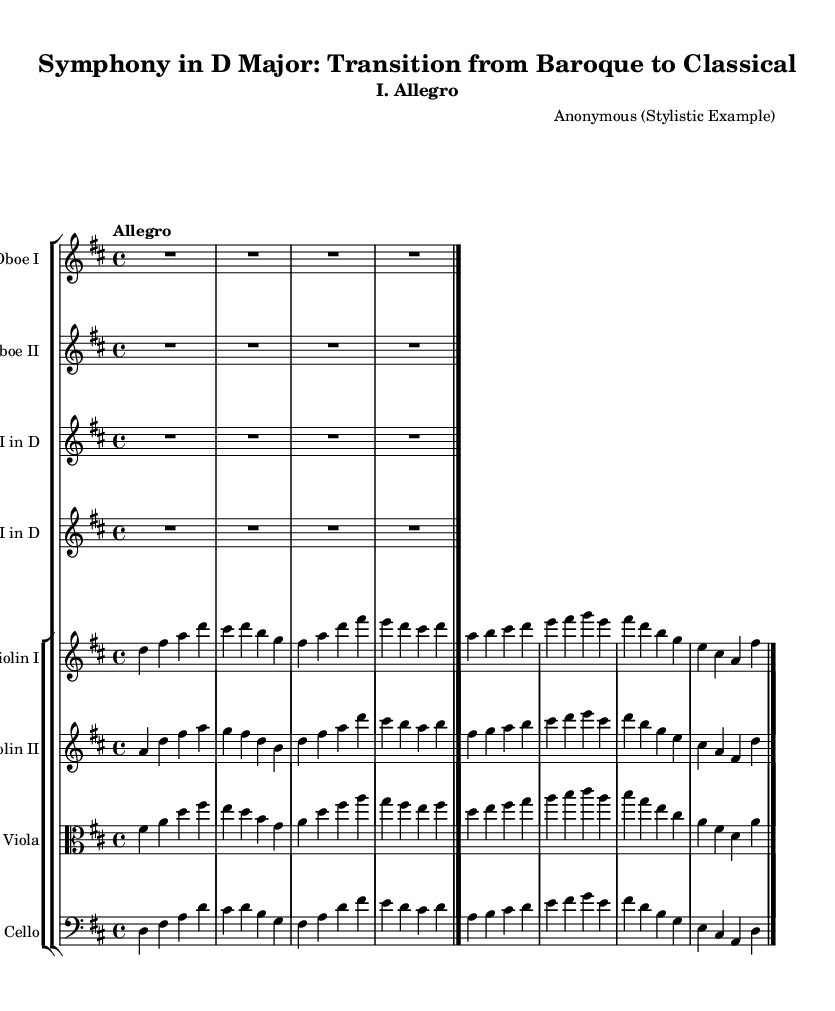What is the key signature of this music? The key signature indicates that the piece is in D major, which has two sharps (F# and C#). You can confirm this by locating the key signature at the beginning of the staff.
Answer: D major What is the time signature of this music? The time signature shown at the beginning of the staff is 4/4, indicating that there are four beats in each measure and the quarter note gets one beat. This can be found next to the clef and key signature.
Answer: 4/4 What is the tempo marking for this piece? The tempo marking written above the staff specifies "Allegro," which indicates a fast, lively pace. This is a typical tempo marking found in the performance direction at the start of the piece.
Answer: Allegro How many instruments are present in this score? The score features a total of six instruments: two violins, one viola, one cello, and two oboes, and two horns, confirmed by counting each instrumental part listed.
Answer: Six What structure is evident in the orchestration of this symphony? The orchestration shows a blend of strings (violins, viola, cello) and woodwinds (oboes) along with brass (horns), which is characteristic of early Classical symphonies, showcasing the transition from Baroque who typically featured strings predominantly.
Answer: Blended orchestration What is the relationship between the dynamics and instrument roles in this symphony? The dynamics in this early Classical piece typically reflect the varying textures and roles of the instruments; for instance, the strings often carry the main melody while woodwinds and brass provide harmonic support, highlighting a more defined orchestral color.
Answer: Contrast in roles 